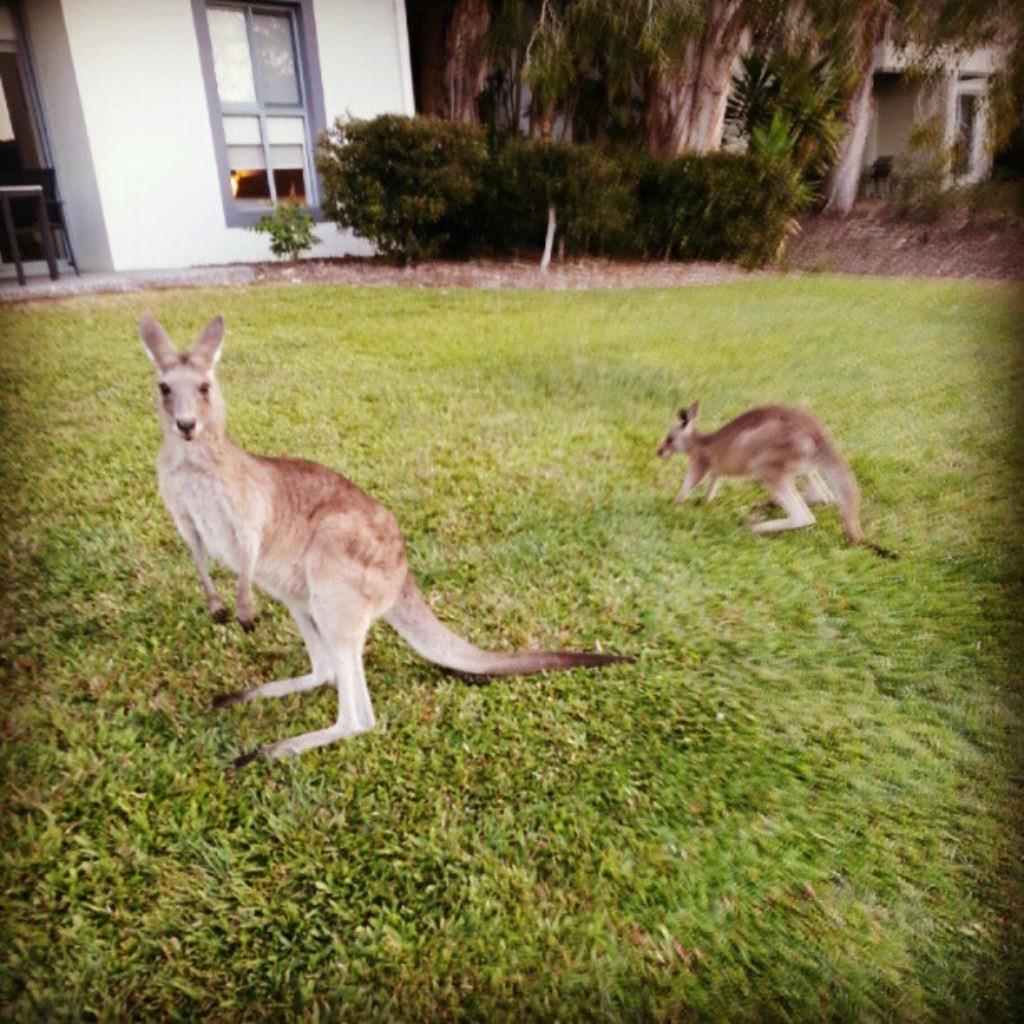Describe this image in one or two sentences. In this image we can see two animals standing on the ground. In the background, we can see a group of trees, building with window and some plants. 